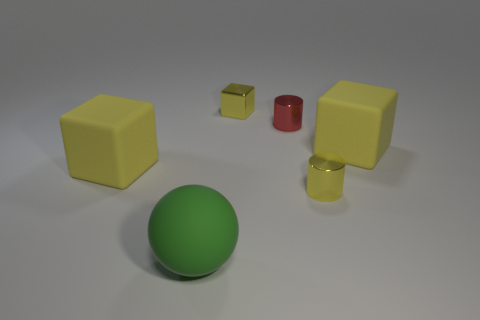Are there any purple matte balls?
Make the answer very short. No. Are there any other things that have the same material as the large green ball?
Your answer should be compact. Yes. Is there a big green thing made of the same material as the tiny red cylinder?
Provide a succinct answer. No. There is another cylinder that is the same size as the yellow cylinder; what is it made of?
Give a very brief answer. Metal. How many other green rubber things have the same shape as the green thing?
Keep it short and to the point. 0. There is a yellow cube that is made of the same material as the tiny yellow cylinder; what size is it?
Your response must be concise. Small. What is the cube that is both in front of the small red metal cylinder and to the right of the big green ball made of?
Offer a very short reply. Rubber. How many spheres are the same size as the metallic cube?
Offer a very short reply. 0. There is another small thing that is the same shape as the red metallic object; what material is it?
Give a very brief answer. Metal. How many objects are either yellow metal objects that are on the left side of the red shiny cylinder or shiny objects on the left side of the tiny red metal thing?
Offer a very short reply. 1. 